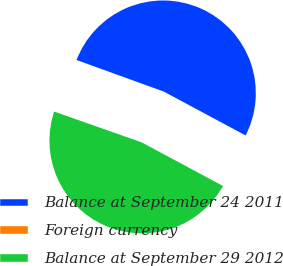<chart> <loc_0><loc_0><loc_500><loc_500><pie_chart><fcel>Balance at September 24 2011<fcel>Foreign currency<fcel>Balance at September 29 2012<nl><fcel>52.3%<fcel>0.15%<fcel>47.55%<nl></chart> 